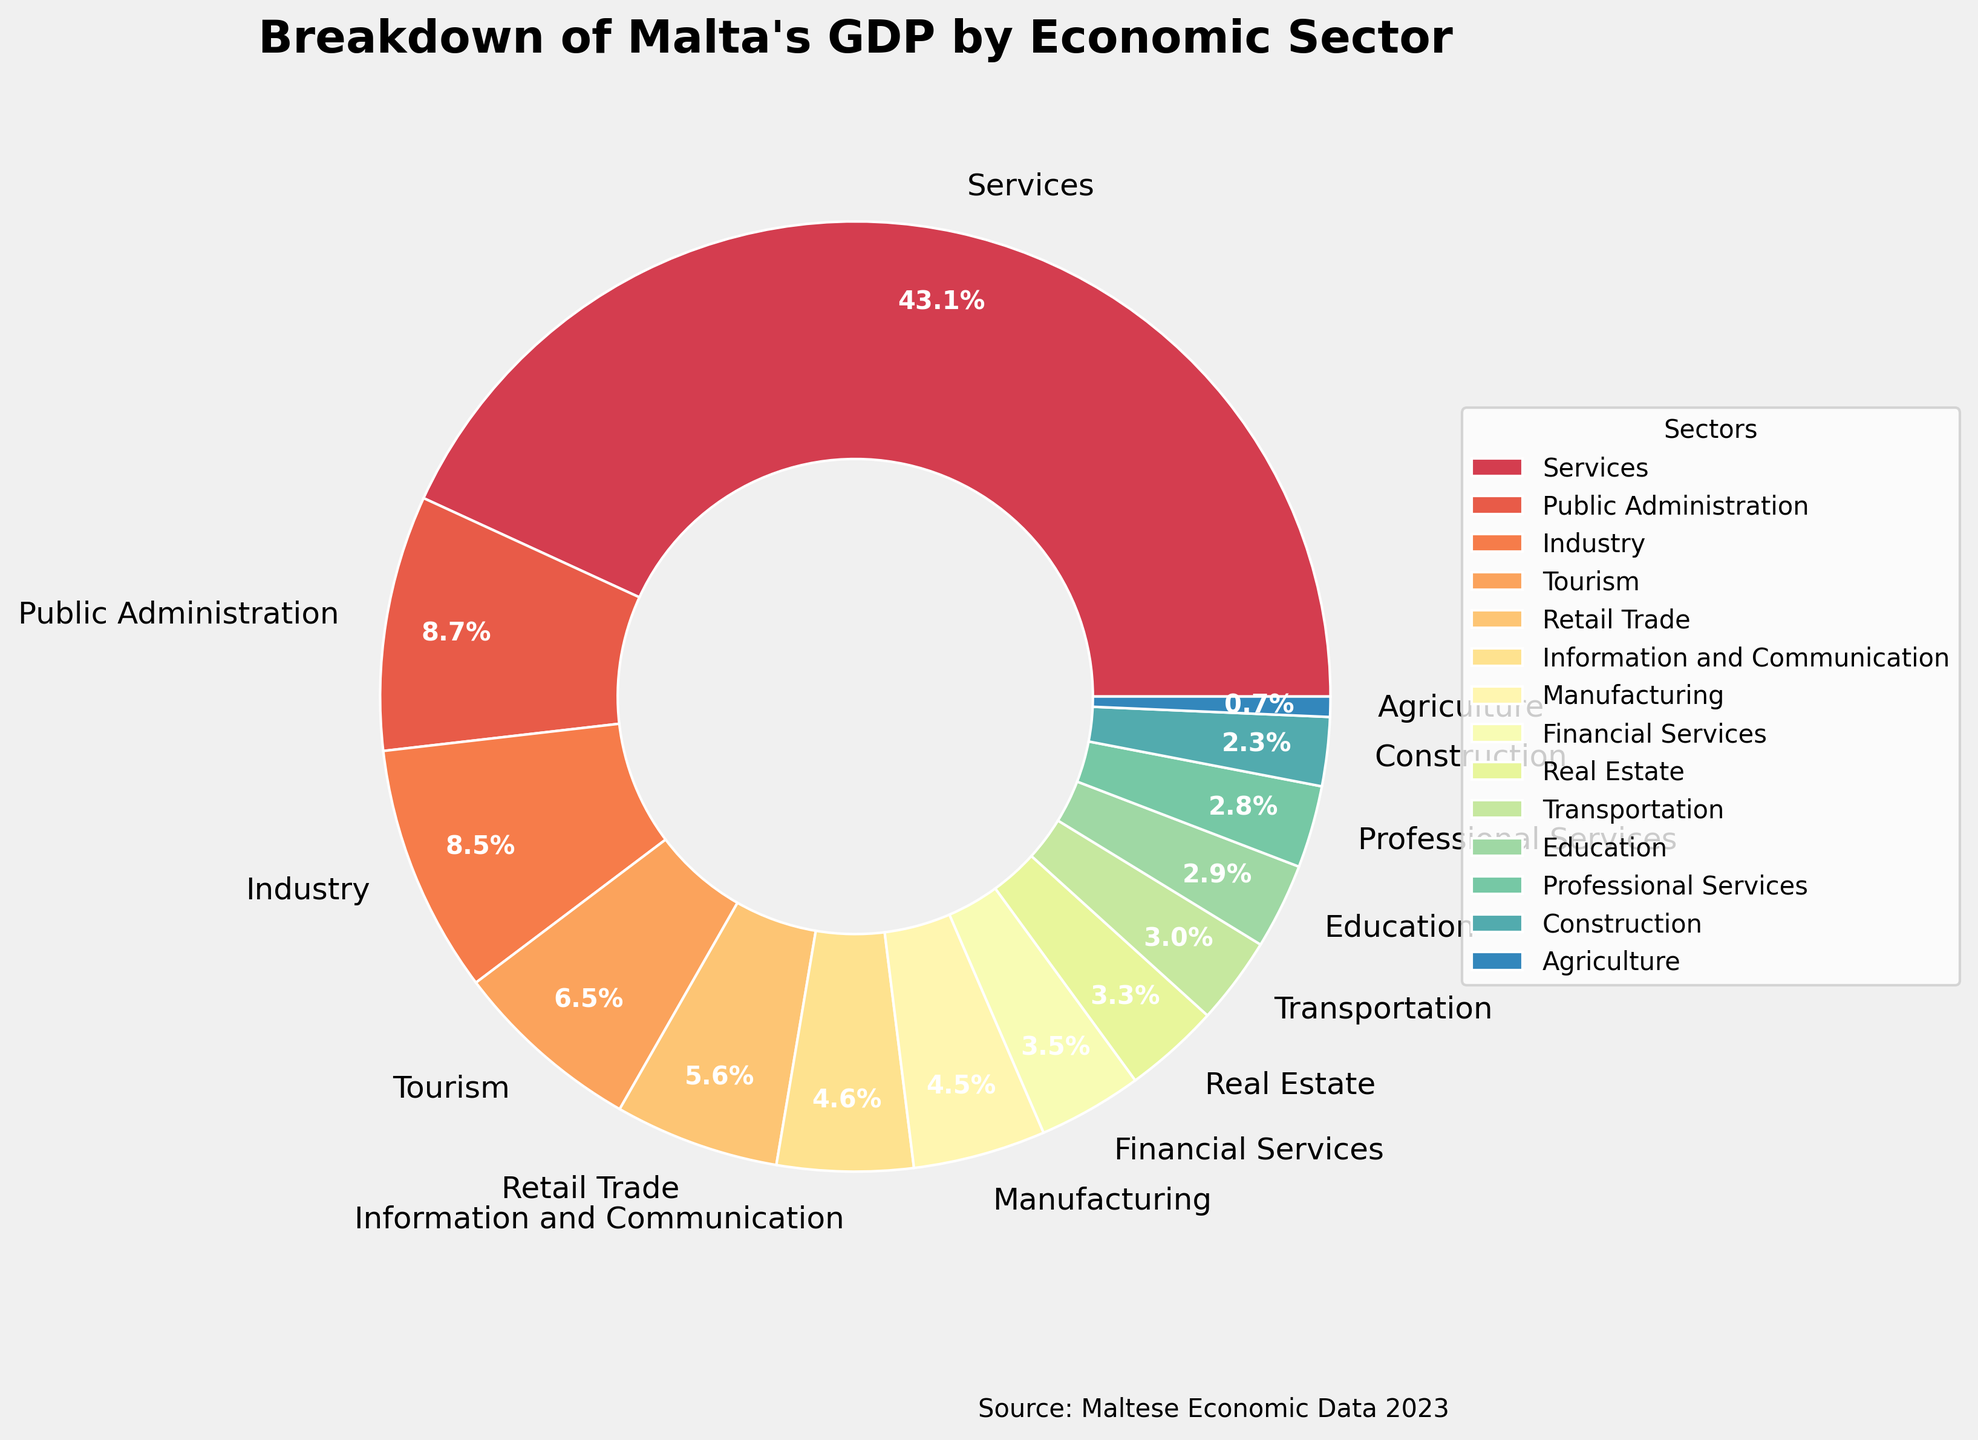Which sector contributes the most to Malta's GDP? By looking at the pie chart, we can see that the largest segment is labeled "Services" with a percentage of 75.5%. This indicates that Services is the sector that contributes the most to Malta's GDP.
Answer: Services What is the total percentage contribution of the Industry and Manufacturing sectors combined? According to the pie chart, Industry contributes 14.8% and Manufacturing contributes 7.9%. Adding these percentages together gives 14.8% + 7.9% = 22.7%.
Answer: 22.7% Which sector ranks just below Services in terms of GDP contribution? In the pie chart, the next largest segment after Services is labeled "Public Administration" with a percentage of 15.2%. Therefore, Public Administration ranks just below Services.
Answer: Public Administration How much more does the Tourism sector contribute to GDP compared to Agriculture? The pie chart shows that Tourism contributes 11.3% while Agriculture contributes 1.2%. The difference is 11.3% - 1.2% = 10.1%.
Answer: 10.1% Which sector has a visually similar color to Retail Trade? Looking at the visual attributes, Professional Services and Education are sectors with colors that are adjacent or similar to Retail Trade. The exact sector with a visually similar color would depend on the exact palette, but typically Professional Services or Education might share a similar hue.
Answer: Professional Services/Education What proportion of Malta's GDP is contributed by all sectors other than Services? The pie chart shows Services contributes 75.5%. Therefore, the contribution of all other sectors combined is 100% - 75.5% = 24.5%.
Answer: 24.5% What is the GDP contribution difference between Information and Communication and Financial Services? The pie chart shows Information and Communication with 8.1% and Financial Services with 6.2%. The difference is 8.1% - 6.2% = 1.9%.
Answer: 1.9% Arrange the following sectors in ascending order of their GDP contribution: Manufacturing, Construction, and Real Estate. According to the pie chart, Manufacturing contributes 7.9%, Construction contributes 4.1%, and Real Estate contributes 5.7%. Arranging these in ascending order gives Construction, Real Estate, and Manufacturing.
Answer: Construction, Real Estate, Manufacturing 